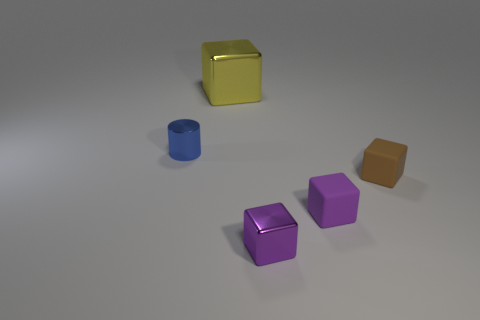Is there any other thing that is the same size as the yellow object?
Your response must be concise. No. What color is the block that is behind the block that is on the right side of the matte block that is to the left of the tiny brown thing?
Your response must be concise. Yellow. There is a brown thing that is the same size as the purple matte object; what is its shape?
Ensure brevity in your answer.  Cube. Is the number of blue metal cylinders greater than the number of large gray shiny balls?
Provide a succinct answer. Yes. There is a shiny thing on the left side of the large yellow thing; are there any small metallic objects on the right side of it?
Keep it short and to the point. Yes. What is the color of the other tiny matte thing that is the same shape as the small brown thing?
Keep it short and to the point. Purple. Is there any other thing that has the same shape as the blue metallic thing?
Provide a short and direct response. No. There is a small cube that is the same material as the small blue object; what color is it?
Make the answer very short. Purple. There is a matte object that is on the left side of the small matte block on the right side of the small purple rubber thing; is there a tiny cube in front of it?
Ensure brevity in your answer.  Yes. Is the number of small blue metallic cylinders that are to the right of the brown matte object less than the number of brown things to the right of the small purple rubber cube?
Your answer should be very brief. Yes. 